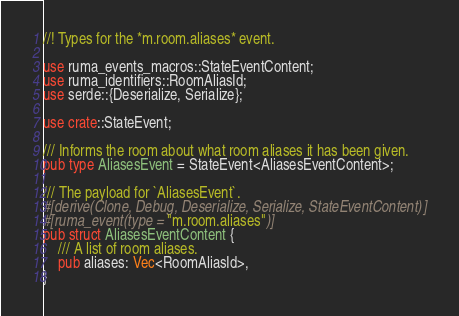<code> <loc_0><loc_0><loc_500><loc_500><_Rust_>//! Types for the *m.room.aliases* event.

use ruma_events_macros::StateEventContent;
use ruma_identifiers::RoomAliasId;
use serde::{Deserialize, Serialize};

use crate::StateEvent;

/// Informs the room about what room aliases it has been given.
pub type AliasesEvent = StateEvent<AliasesEventContent>;

/// The payload for `AliasesEvent`.
#[derive(Clone, Debug, Deserialize, Serialize, StateEventContent)]
#[ruma_event(type = "m.room.aliases")]
pub struct AliasesEventContent {
    /// A list of room aliases.
    pub aliases: Vec<RoomAliasId>,
}
</code> 